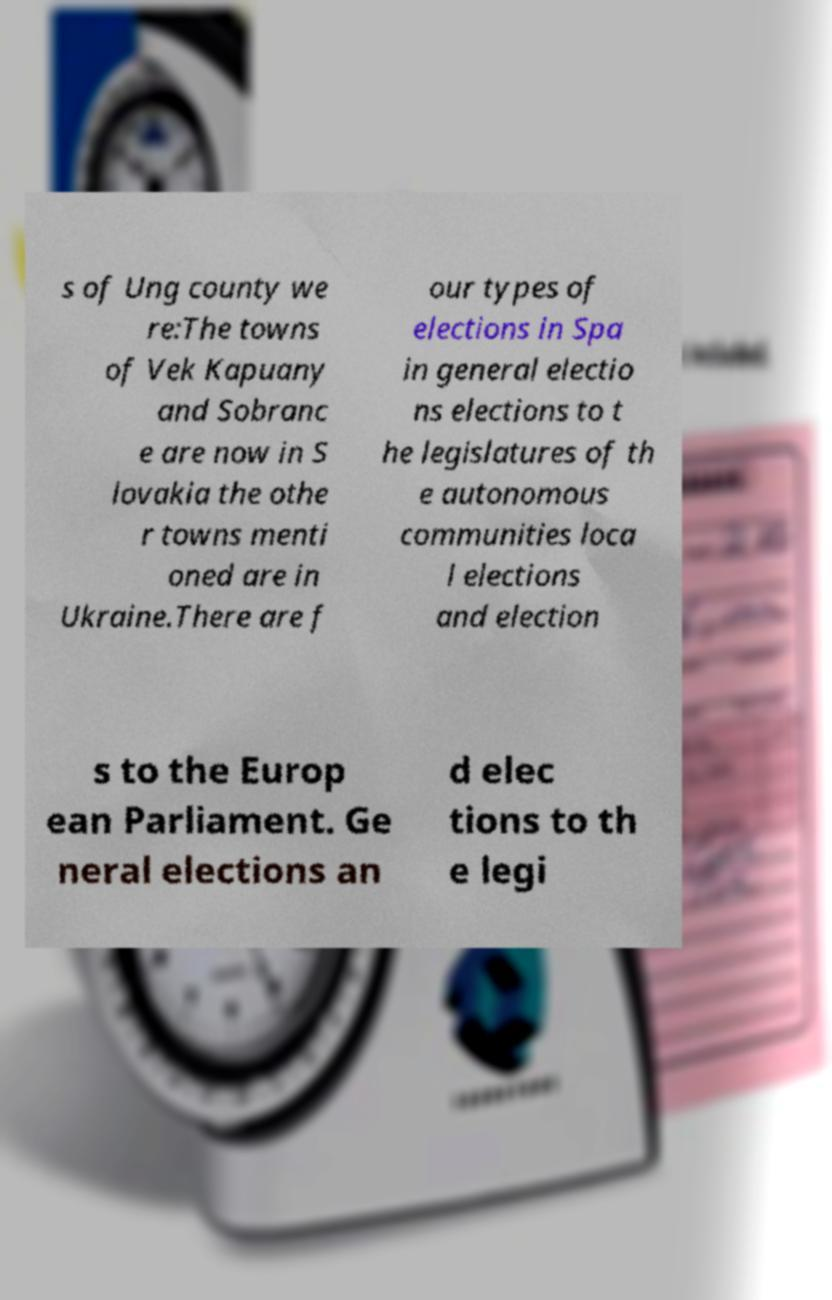There's text embedded in this image that I need extracted. Can you transcribe it verbatim? s of Ung county we re:The towns of Vek Kapuany and Sobranc e are now in S lovakia the othe r towns menti oned are in Ukraine.There are f our types of elections in Spa in general electio ns elections to t he legislatures of th e autonomous communities loca l elections and election s to the Europ ean Parliament. Ge neral elections an d elec tions to th e legi 